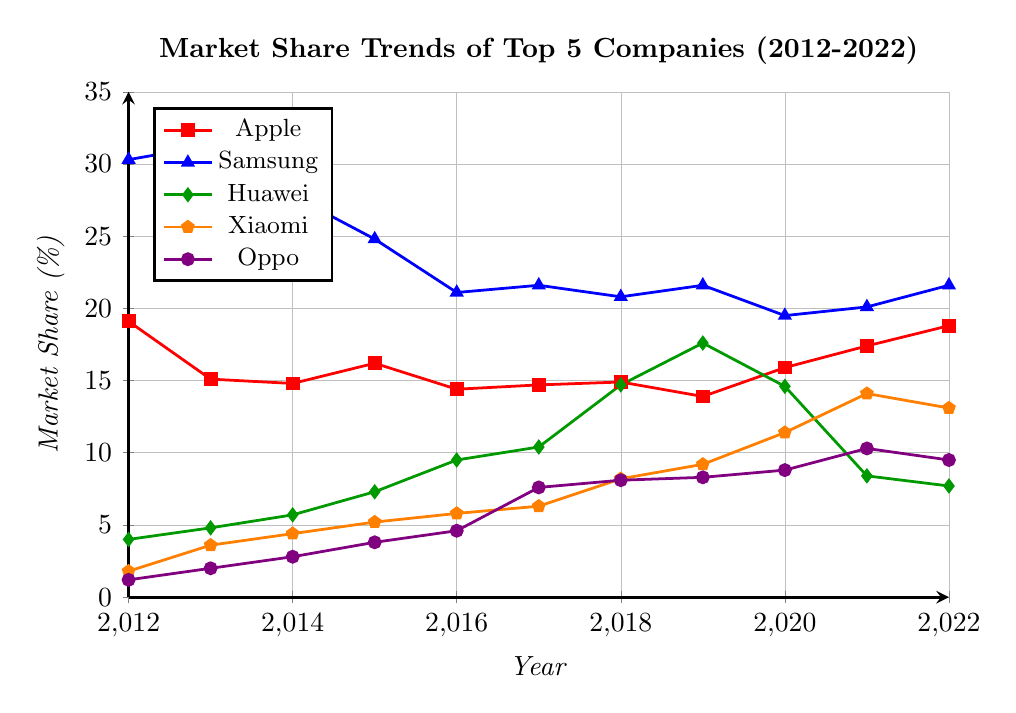Which company had the highest market share in 2012? To find the highest market share in 2012, locate the corresponding data values for each company in that year. The values are Apple (19.1), Samsung (30.3), Huawei (4.0), Xiaomi (1.8), and Oppo (1.2). Comparing these, Samsung has the highest value.
Answer: Samsung What is the average market share of Huawei across the decade? Sum up Huawei's market share values from 2012 to 2022 and then divide by the number of years. The values are 4.0, 4.8, 5.7, 7.3, 9.5, 10.4, 14.7, 17.6, 14.6, 8.4, and 7.7. Sum is 105.7. Average = 105.7 / 11 = 9.61
Answer: 9.61 Which two companies showed a consistent increase or stability in their market share from 2012 to 2022? Check the trend lines for each company from 2012 to 2022. Apple, Samsung, and Huawei have fluctuating trends. Xiaomi and Oppo show a largely upward trend.
Answer: Xiaomi, Oppo In which year did Samsung have its lowest market share during the plotted period? Identify the lowest point on Samsung's trend line. The values are 30.3, 31.3, 27.8, 24.8, 21.1, 21.6, 20.8, 21.6, 19.5, 20.1, and 21.6. The lowest value is 19.5 in 2020.
Answer: 2020 What is the total market share of all companies in 2020? Add the market share values of all companies for the year 2020: Apple (15.9), Samsung (19.5), Huawei (14.6), Xiaomi (11.4), Oppo (8.8). Sum = 15.9 + 19.5 + 14.6 + 11.4 + 8.8 = 70.2
Answer: 70.2 Which company had the biggest drop in market share between any two consecutive years, and in which years did this occur? Calculate the market share differences between consecutive years for each company and identify the largest drop. The largest drop is Huawei from 2019 to 2021, with a decrease from 17.6 to 8.4, dropping by 9.2.
Answer: Huawei, 2019-2021 By how much did Xiaomi's market share increase from its lowest point to its highest point during this period? Identify Xiaomi's lowest (1.8 in 2012) and highest (14.1 in 2021) market share. Subtract the lowest from the highest: 14.1 - 1.8 = 12.3
Answer: 12.3 How did Apple's market share in 2022 compare to its market share in 2012? Look at the values for Apple in 2012 (19.1) and 2022 (18.8). Compare these values: 18.8 is slightly less than 19.1, indicating a small decrease.
Answer: Decreased Which year saw Apple's closest market share to Huawei? Compare the annual market share values for Apple and Huawei to identify the smallest difference. The smallest difference is in 2020: Apple (15.9), Huawei (14.6) with a difference of 1.3.
Answer: 2020 